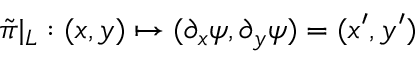<formula> <loc_0><loc_0><loc_500><loc_500>\tilde { \pi } | _ { L } \colon ( x , y ) \mapsto ( \partial _ { x } \psi , \partial _ { y } \psi ) = ( x ^ { \prime } , y ^ { \prime } )</formula> 